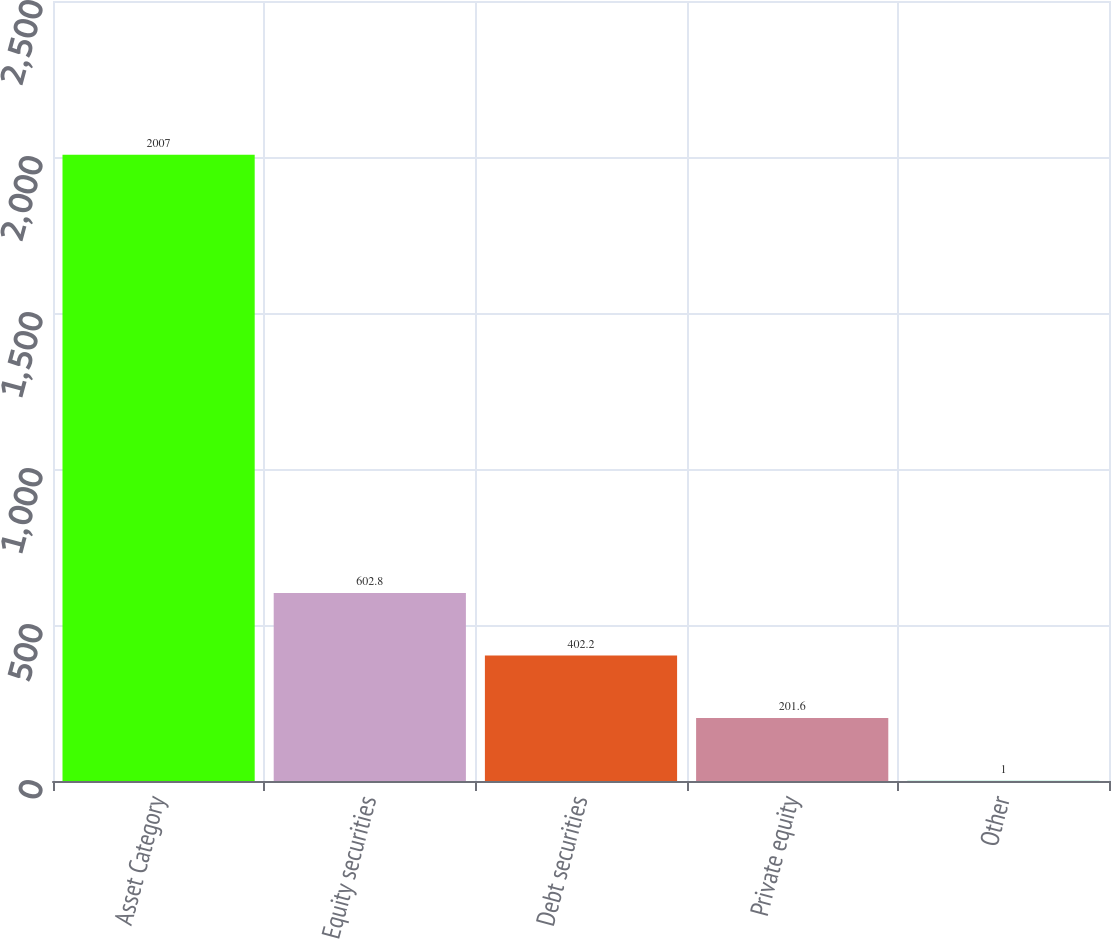Convert chart to OTSL. <chart><loc_0><loc_0><loc_500><loc_500><bar_chart><fcel>Asset Category<fcel>Equity securities<fcel>Debt securities<fcel>Private equity<fcel>Other<nl><fcel>2007<fcel>602.8<fcel>402.2<fcel>201.6<fcel>1<nl></chart> 